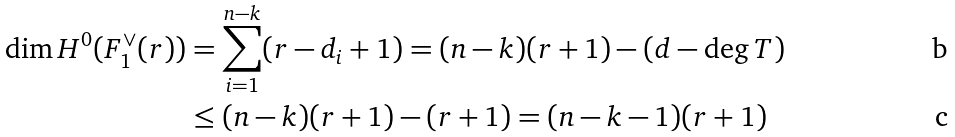<formula> <loc_0><loc_0><loc_500><loc_500>\dim H ^ { 0 } ( F _ { 1 } ^ { \vee } ( r ) ) & = \sum _ { i = 1 } ^ { n - k } ( r - d _ { i } + 1 ) = ( n - k ) ( r + 1 ) - ( d - \deg T ) \\ & \leq ( n - k ) ( r + 1 ) - ( r + 1 ) = ( n - k - 1 ) ( r + 1 )</formula> 